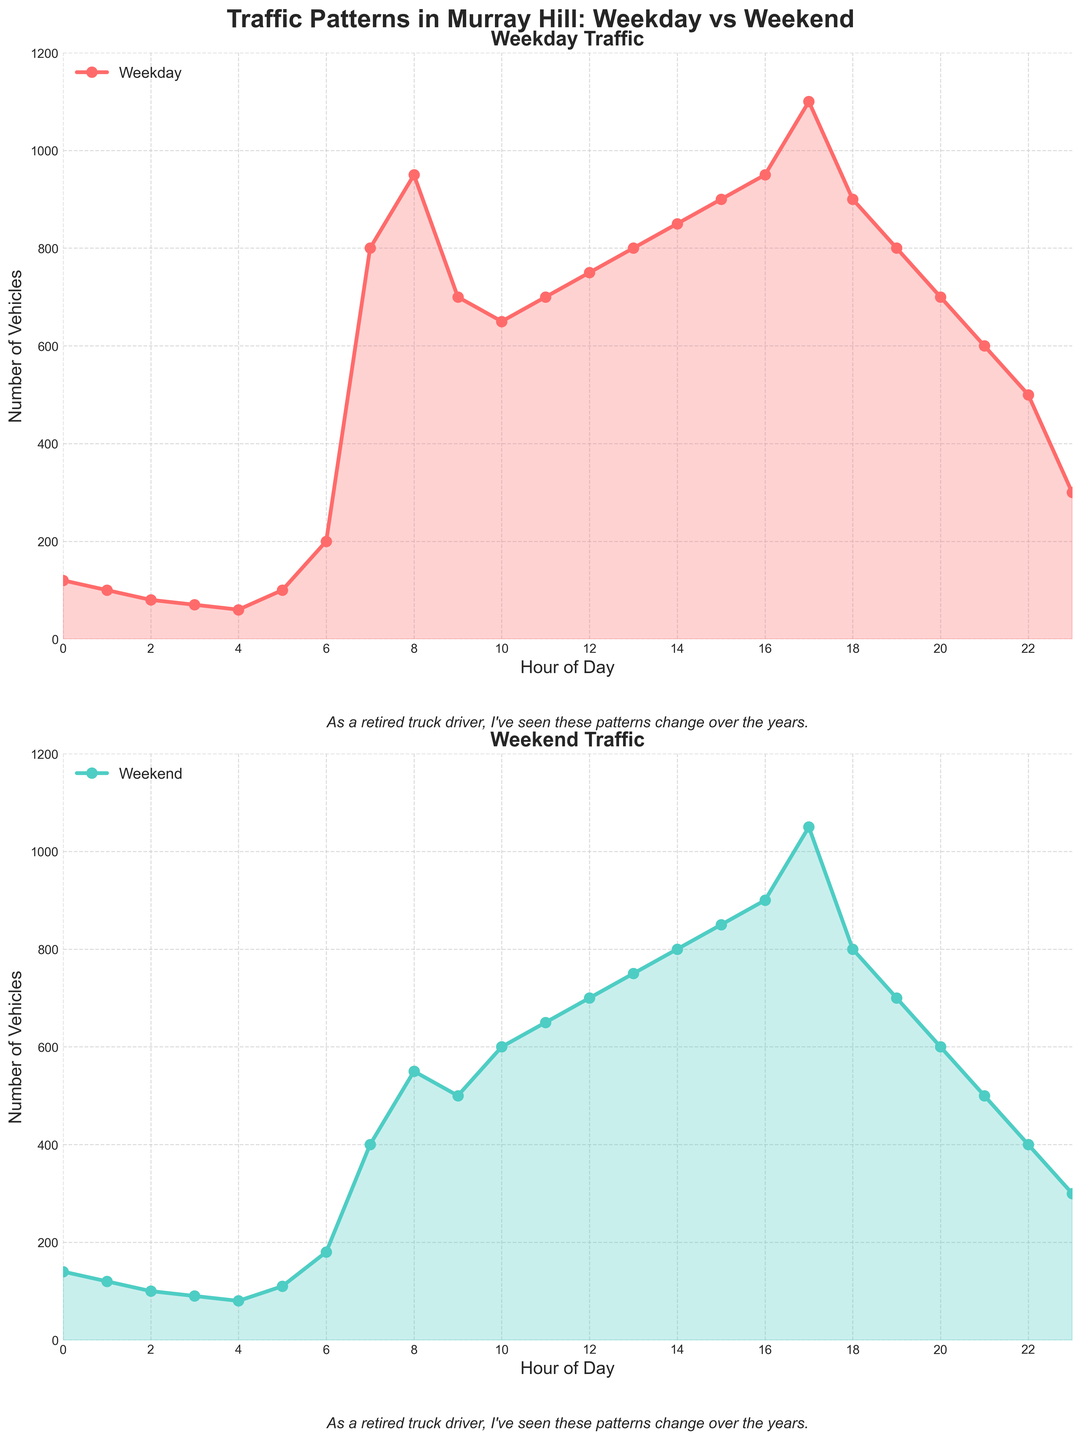What is the title of the figure? The title of the figure is at the top and it reads "Traffic Patterns in Murray Hill: Weekday vs Weekend".
Answer: Traffic Patterns in Murray Hill: Weekday vs Weekend How many subplots are there in the figure? There are two subplots arranged vertically, one for Weekday traffic and another for Weekend traffic. This can be observed by the two distinct sections with different labels.
Answer: Two At what time does the weekday traffic peak? The Weekday traffic peaks at 5:00 PM, where the number of vehicles reaches 1100. This can be identified from the highest point on the Weekday traffic plot.
Answer: 5:00 PM How does the number of vehicles at 8:00 AM on weekdays compare to 8:00 AM on weekends? On weekdays, the number of vehicles at 8:00 AM is 950, while on weekends it is 550. The comparison shows that weekday traffic is higher at this time.
Answer: Weekday traffic is higher What is the overall trend in traffic from midnight to 6:00 AM on weekdays? Traffic remains relatively low from midnight to about 5:00 AM and then starts to increase sharply at 6:00 AM. This increasing trend is evident from the rise in the curve starting at 6:00 AM.
Answer: Low until 6:00 AM, then increases Can you identify a time period where weekday traffic significantly exceeds weekend traffic? Between 6:00 AM and 9:00 AM, weekday traffic is significantly higher than weekend traffic, particularly visible with the sharp peaks on weekdays compared to weekends.
Answer: 6:00 AM to 9:00 AM During what time on weekends do we see a significant rise in vehicle numbers? On weekends, a significant rise in vehicle numbers can be observed starting at 7:00 AM, peaking around the middle of the day, specifically around 5:00 PM.
Answer: 7:00 AM to 5:00 PM What is the traffic trend difference between weekdays and weekends in the evening (6 PM to 9 PM)? Weekday traffic declines more sharply after 6 PM compared to weekends. This can be seen by the steep drop on the weekday plot, whereas the weekend plot shows a more gradual decrease.
Answer: Weekdays decline sharply, weekends more gradual What is the number of vehicles at 4:00 PM on both weekdays and weekends? At 4:00 PM, the number of vehicles on weekdays is 950, while on weekends it is 900. This information can be read directly from both plots at the 4:00 PM marker.
Answer: Weekdays: 950, Weekends: 900 What can be inferred about the traffic patterns during late night (after 10 PM) on weekdays and weekends? Both weekdays and weekends show a decreasing trend in traffic after 10 PM, with the number of vehicles dropping significantly by midnight. This can be inferred from the plots showing a consistent downward slope after 10 PM.
Answer: Decreasing trend on both 